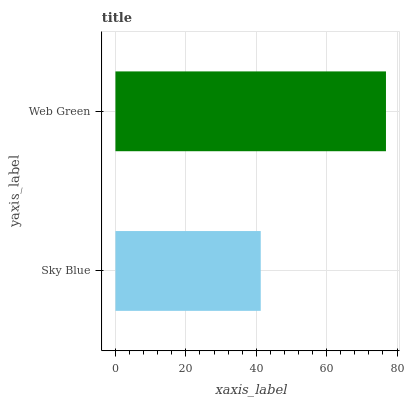Is Sky Blue the minimum?
Answer yes or no. Yes. Is Web Green the maximum?
Answer yes or no. Yes. Is Web Green the minimum?
Answer yes or no. No. Is Web Green greater than Sky Blue?
Answer yes or no. Yes. Is Sky Blue less than Web Green?
Answer yes or no. Yes. Is Sky Blue greater than Web Green?
Answer yes or no. No. Is Web Green less than Sky Blue?
Answer yes or no. No. Is Web Green the high median?
Answer yes or no. Yes. Is Sky Blue the low median?
Answer yes or no. Yes. Is Sky Blue the high median?
Answer yes or no. No. Is Web Green the low median?
Answer yes or no. No. 